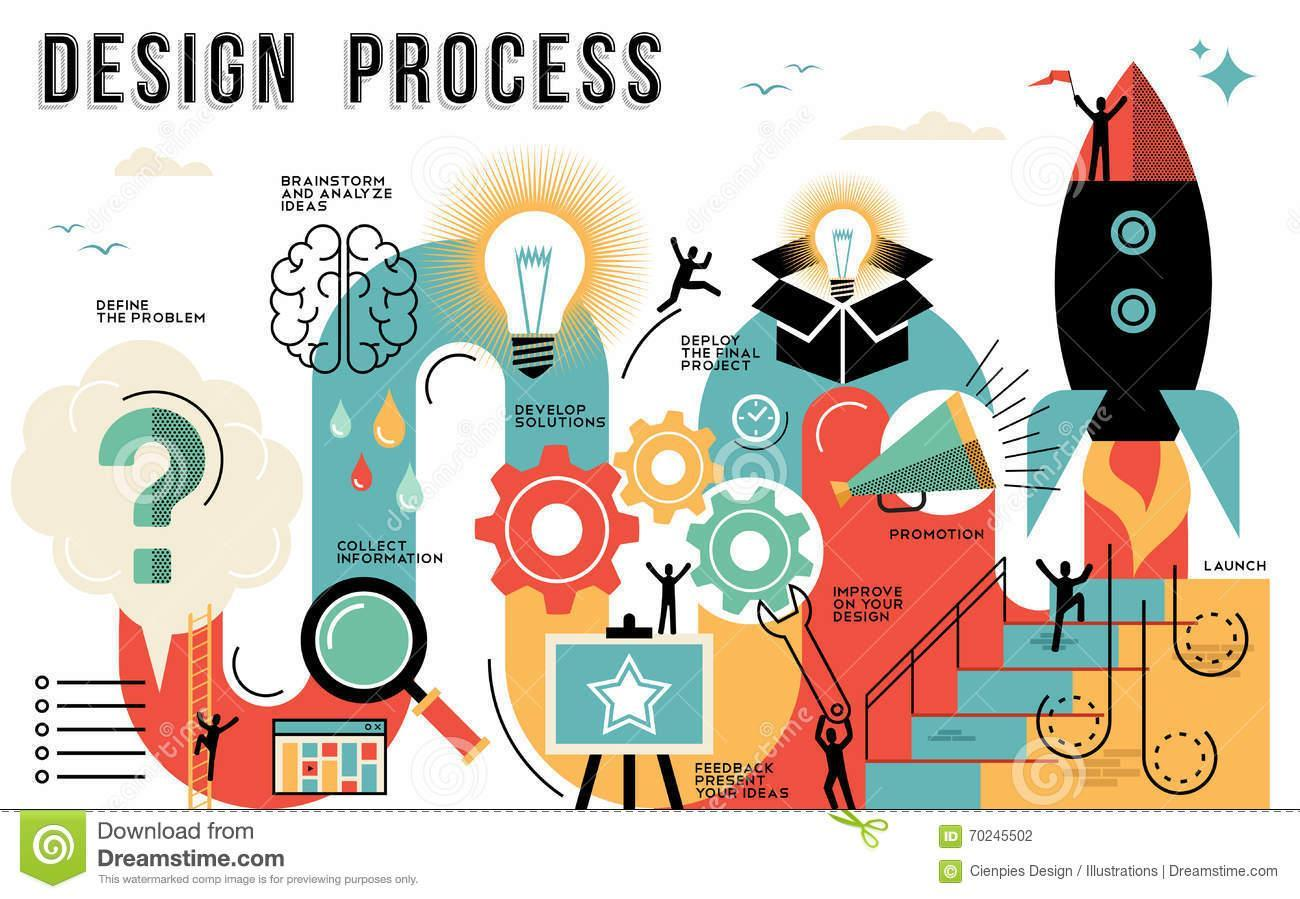What process does the question mark imply
Answer the question with a short phrase. define the problem what process is implied by the magnifying lense collect information What is shown on the notice board, star or moon star what process is defined by the brain brainstorm and analyze ideas What process does the louspeaker show promotion 